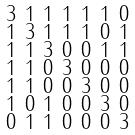Convert formula to latex. <formula><loc_0><loc_0><loc_500><loc_500>\begin{smallmatrix} 3 & 1 & 1 & 1 & 1 & 1 & 0 \\ 1 & 3 & 1 & 1 & 1 & 0 & 1 \\ 1 & 1 & 3 & 0 & 0 & 1 & 1 \\ 1 & 1 & 0 & 3 & 0 & 0 & 0 \\ 1 & 1 & 0 & 0 & 3 & 0 & 0 \\ 1 & 0 & 1 & 0 & 0 & 3 & 0 \\ 0 & 1 & 1 & 0 & 0 & 0 & 3 \end{smallmatrix}</formula> 